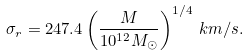<formula> <loc_0><loc_0><loc_500><loc_500>\sigma _ { r } = 2 4 7 . 4 \left ( \frac { M } { 1 0 ^ { 1 2 } M _ { \odot } } \right ) ^ { 1 / 4 } \, k m / s .</formula> 